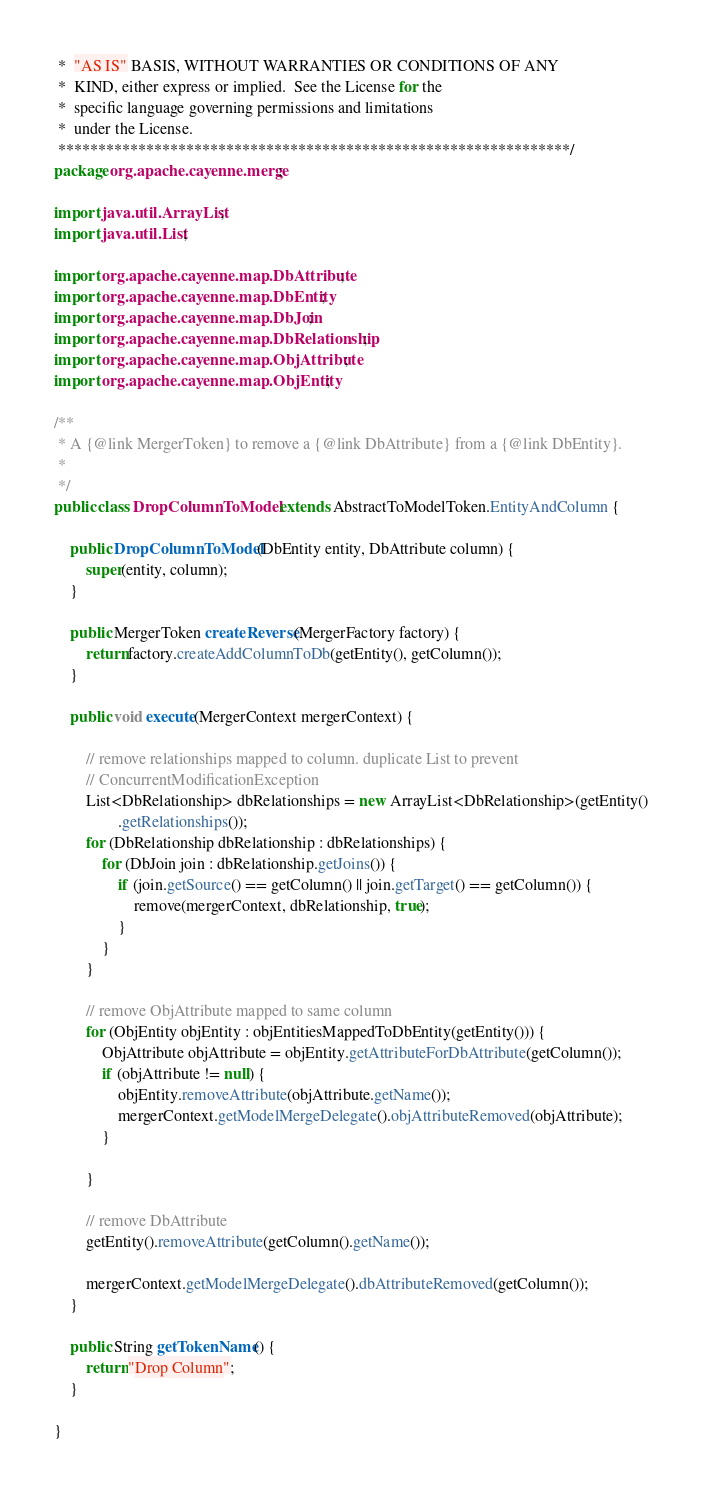Convert code to text. <code><loc_0><loc_0><loc_500><loc_500><_Java_> *  "AS IS" BASIS, WITHOUT WARRANTIES OR CONDITIONS OF ANY
 *  KIND, either express or implied.  See the License for the
 *  specific language governing permissions and limitations
 *  under the License.
 ****************************************************************/
package org.apache.cayenne.merge;

import java.util.ArrayList;
import java.util.List;

import org.apache.cayenne.map.DbAttribute;
import org.apache.cayenne.map.DbEntity;
import org.apache.cayenne.map.DbJoin;
import org.apache.cayenne.map.DbRelationship;
import org.apache.cayenne.map.ObjAttribute;
import org.apache.cayenne.map.ObjEntity;

/**
 * A {@link MergerToken} to remove a {@link DbAttribute} from a {@link DbEntity}.
 * 
 */
public class DropColumnToModel extends AbstractToModelToken.EntityAndColumn {

    public DropColumnToModel(DbEntity entity, DbAttribute column) {
        super(entity, column);
    }

    public MergerToken createReverse(MergerFactory factory) {
        return factory.createAddColumnToDb(getEntity(), getColumn());
    }

    public void execute(MergerContext mergerContext) {

        // remove relationships mapped to column. duplicate List to prevent
        // ConcurrentModificationException
        List<DbRelationship> dbRelationships = new ArrayList<DbRelationship>(getEntity()
                .getRelationships());
        for (DbRelationship dbRelationship : dbRelationships) {
            for (DbJoin join : dbRelationship.getJoins()) {
                if (join.getSource() == getColumn() || join.getTarget() == getColumn()) {
                    remove(mergerContext, dbRelationship, true);
                }
            }
        }

        // remove ObjAttribute mapped to same column
        for (ObjEntity objEntity : objEntitiesMappedToDbEntity(getEntity())) {
            ObjAttribute objAttribute = objEntity.getAttributeForDbAttribute(getColumn());
            if (objAttribute != null) {
                objEntity.removeAttribute(objAttribute.getName());
                mergerContext.getModelMergeDelegate().objAttributeRemoved(objAttribute);
            }

        }

        // remove DbAttribute
        getEntity().removeAttribute(getColumn().getName());

        mergerContext.getModelMergeDelegate().dbAttributeRemoved(getColumn());
    }

    public String getTokenName() {
        return "Drop Column";
    }

}
</code> 